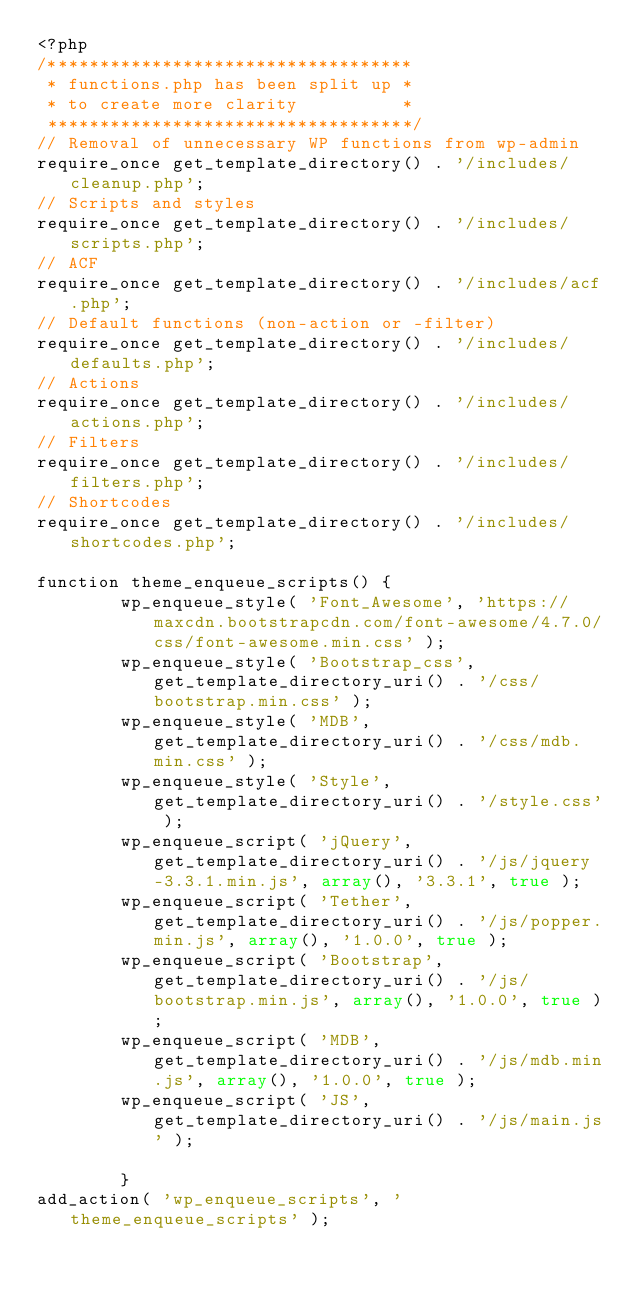<code> <loc_0><loc_0><loc_500><loc_500><_PHP_><?php
/***********************************
 * functions.php has been split up *
 * to create more clarity          *
 ***********************************/
// Removal of unnecessary WP functions from wp-admin
require_once get_template_directory() . '/includes/cleanup.php';
// Scripts and styles
require_once get_template_directory() . '/includes/scripts.php';
// ACF
require_once get_template_directory() . '/includes/acf.php';
// Default functions (non-action or -filter)
require_once get_template_directory() . '/includes/defaults.php';
// Actions
require_once get_template_directory() . '/includes/actions.php';
// Filters
require_once get_template_directory() . '/includes/filters.php';
// Shortcodes
require_once get_template_directory() . '/includes/shortcodes.php';

function theme_enqueue_scripts() {
        wp_enqueue_style( 'Font_Awesome', 'https://maxcdn.bootstrapcdn.com/font-awesome/4.7.0/css/font-awesome.min.css' );
        wp_enqueue_style( 'Bootstrap_css', get_template_directory_uri() . '/css/bootstrap.min.css' );
        wp_enqueue_style( 'MDB', get_template_directory_uri() . '/css/mdb.min.css' );
        wp_enqueue_style( 'Style', get_template_directory_uri() . '/style.css' );
        wp_enqueue_script( 'jQuery', get_template_directory_uri() . '/js/jquery-3.3.1.min.js', array(), '3.3.1', true );
        wp_enqueue_script( 'Tether', get_template_directory_uri() . '/js/popper.min.js', array(), '1.0.0', true );
        wp_enqueue_script( 'Bootstrap', get_template_directory_uri() . '/js/bootstrap.min.js', array(), '1.0.0', true );
        wp_enqueue_script( 'MDB', get_template_directory_uri() . '/js/mdb.min.js', array(), '1.0.0', true );
        wp_enqueue_script( 'JS', get_template_directory_uri() . '/js/main.js' );

        }
add_action( 'wp_enqueue_scripts', 'theme_enqueue_scripts' );
</code> 